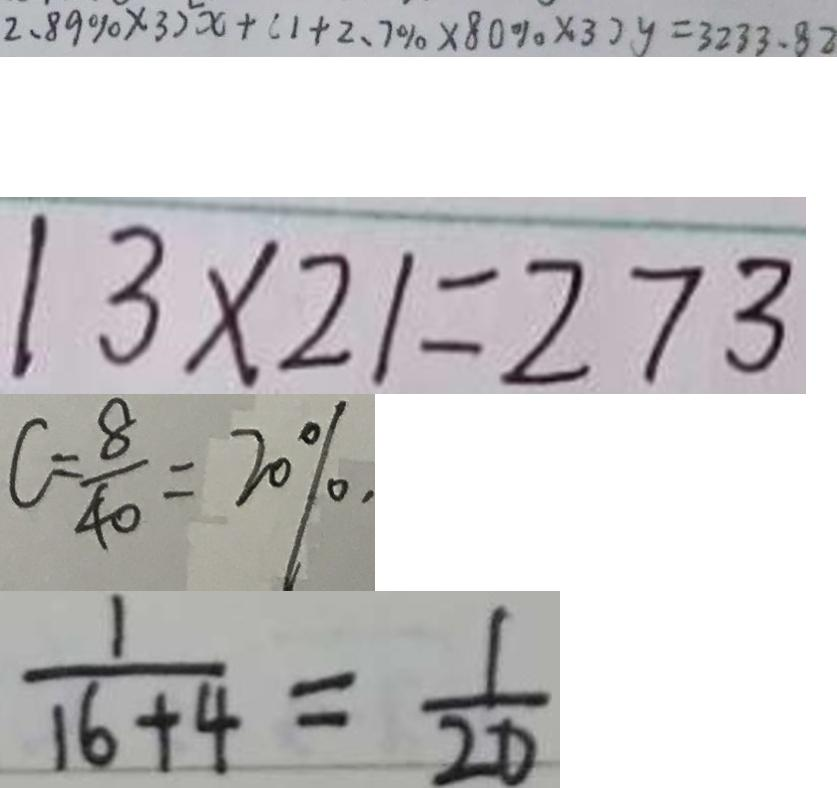<formula> <loc_0><loc_0><loc_500><loc_500>2 . 8 9 \% \times 3 ) ^ { 2 } x + ( 1 + 2 . 7 \% \times 8 0 \% \times 3 ) y = 3 2 3 3 . 8 2 
 1 3 \times 2 1 = 2 7 3 
 C = \frac { 8 } { 4 0 } = 2 0 \% 
 \frac { 1 } { 1 6 + 4 } = \frac { 1 } { 2 0 }</formula> 